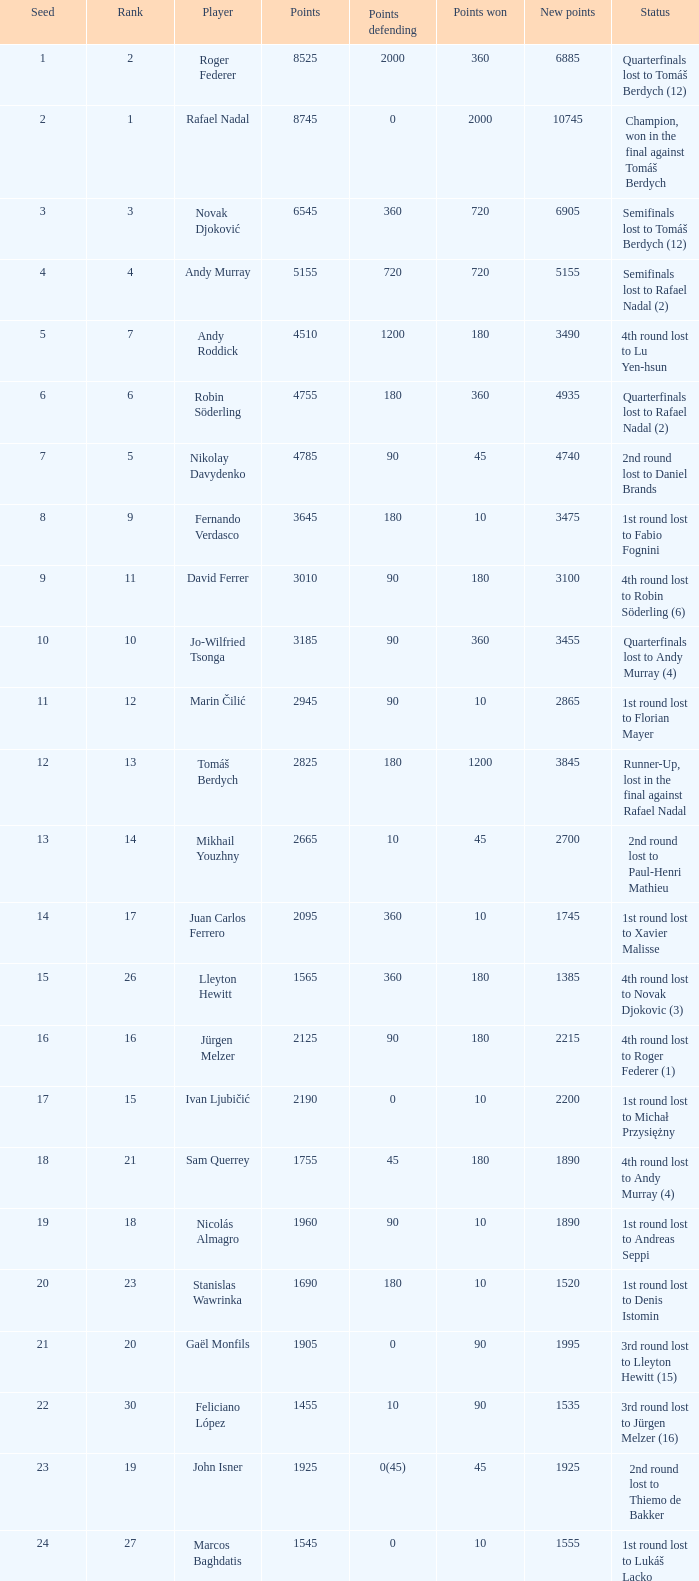What is the quantity of points to be defended for 1075? 1.0. 